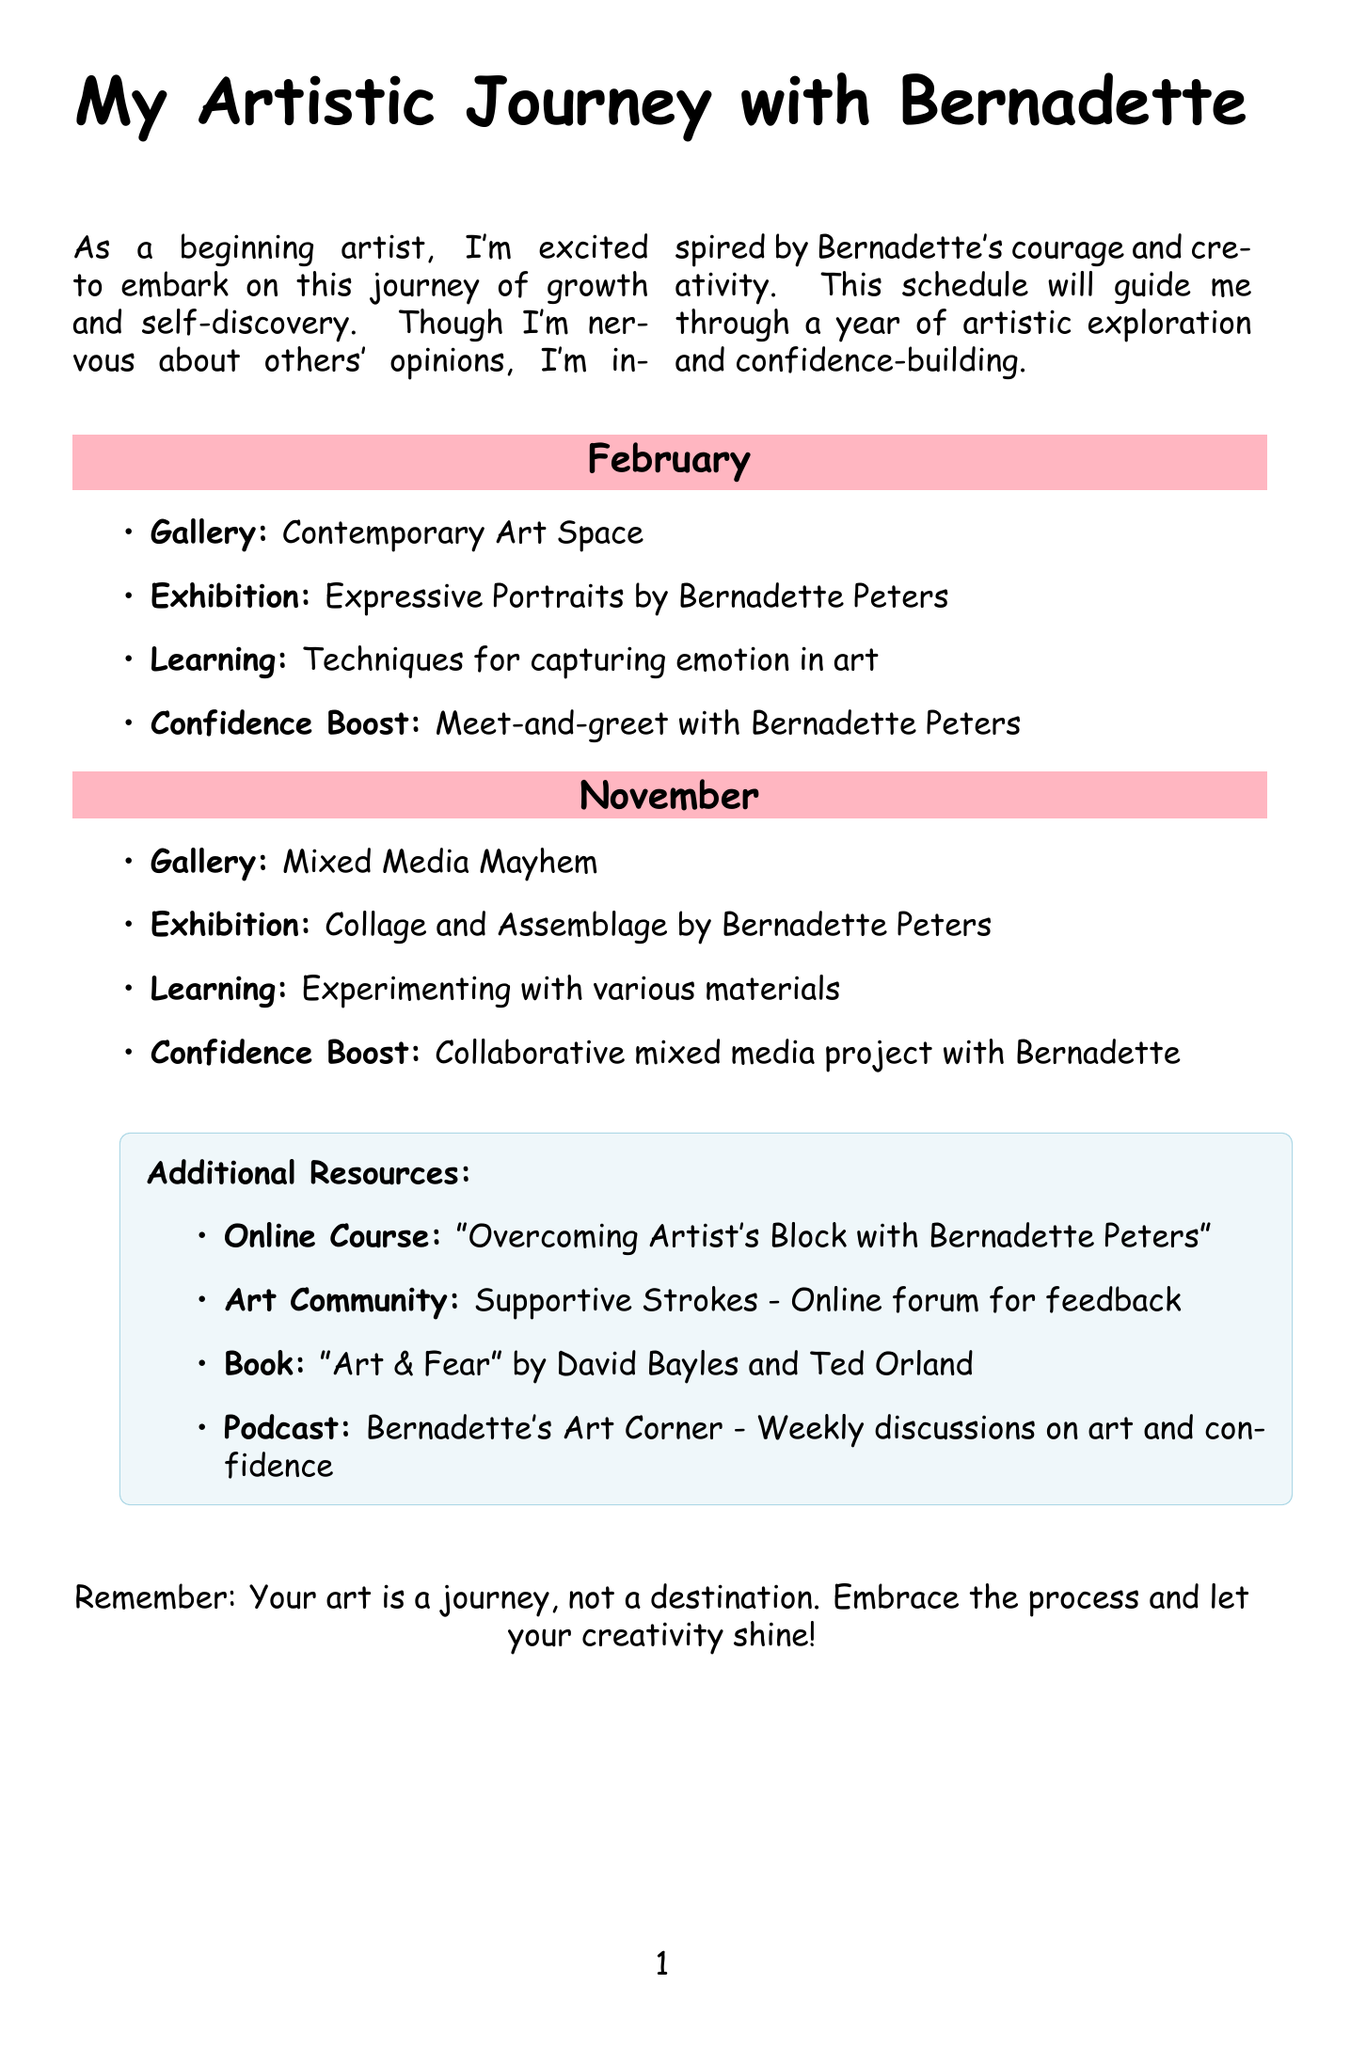What is the featured artist for February? The document specifies that Bernadette Peters is the featured artist for February.
Answer: Bernadette Peters What is the exhibition theme in November? The exhibition theme for November is noted as "Collage and Assemblage."
Answer: Collage and Assemblage What is the relevance of the January exhibition to a beginner artist? The document states the relevance as "Study of color and nature in paintings."
Answer: Study of color and nature in paintings What confidence-boosting activity is scheduled for May? For May, the specified activity is "Collaborative infinity room installation."
Answer: Collaborative infinity room installation In which gallery will the outdoor sketching workshop take place? The document mentions that the Urban Sketchers Collective will host the outdoor sketching workshop.
Answer: Urban Sketchers Collective Which artist is featured in the exhibition on self-portraits in April? Frida Kahlo is the featured artist for the exhibition in April.
Answer: Frida Kahlo How many months feature Bernadette Peters as the artist? The document indicates that Bernadette Peters appears in two months, February and November.
Answer: Two What is the resource type of "Overcoming Artist's Block with Bernadette Peters"? This is categorized as an "Online Course" within the additional resources.
Answer: Online Course What are the techniques highlighted in the exhibition by Annie Leibovitz? The document notes that the focus is on "Composition and lighting techniques" in October.
Answer: Composition and lighting techniques 